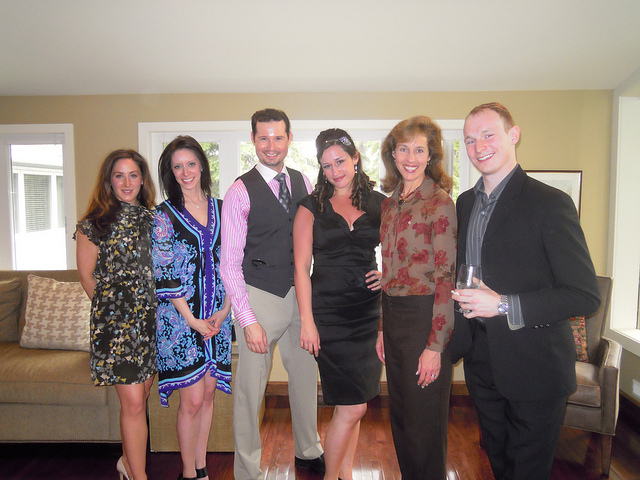<image>What type of pants are the majority of the woman wearing? It is ambiguous what type of pants the women are wearing as they could be wearing dresses or skirts. What type of pants are the majority of the woman wearing? I am not sure what type of pants the majority of the women are wearing. There are none or dresses. 